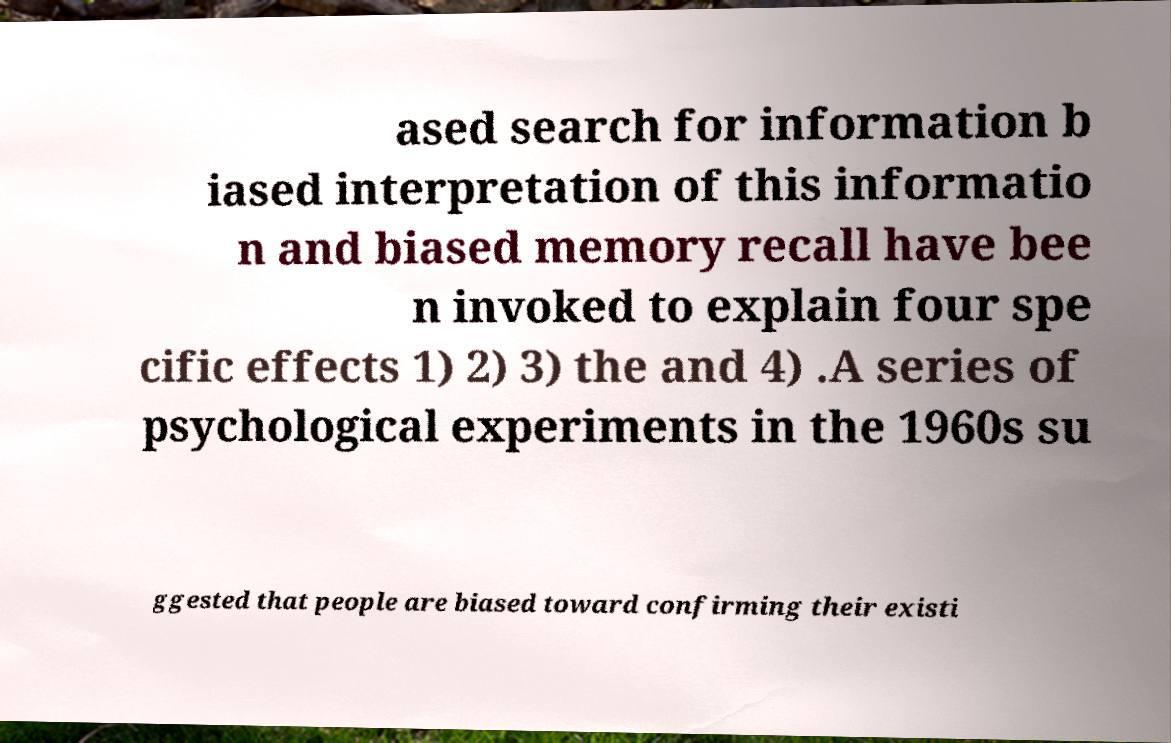There's text embedded in this image that I need extracted. Can you transcribe it verbatim? ased search for information b iased interpretation of this informatio n and biased memory recall have bee n invoked to explain four spe cific effects 1) 2) 3) the and 4) .A series of psychological experiments in the 1960s su ggested that people are biased toward confirming their existi 